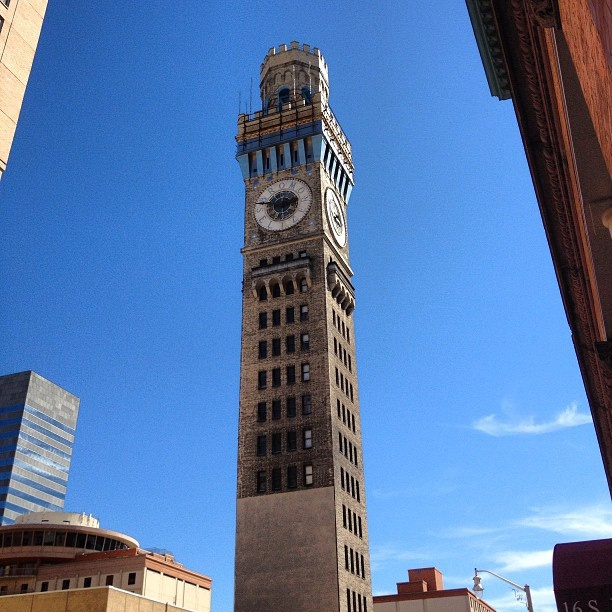Describe the objects in this image and their specific colors. I can see clock in darkgray, gray, and black tones and clock in darkgray, white, gray, and black tones in this image. 